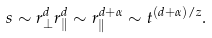<formula> <loc_0><loc_0><loc_500><loc_500>s \sim r _ { \perp } ^ { d } r _ { \| } ^ { d } \sim r _ { \| } ^ { d + \alpha } \sim t ^ { ( d + \alpha ) / z } .</formula> 